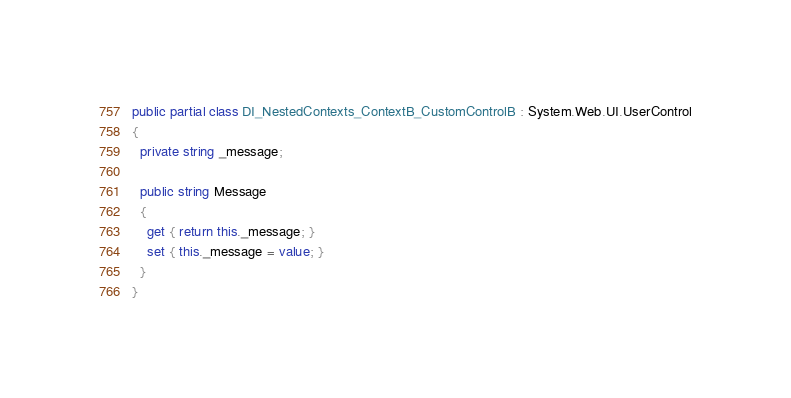<code> <loc_0><loc_0><loc_500><loc_500><_C#_>
public partial class DI_NestedContexts_ContextB_CustomControlB : System.Web.UI.UserControl
{
  private string _message;

  public string Message
  {
    get { return this._message; }
    set { this._message = value; }
  }
}
</code> 